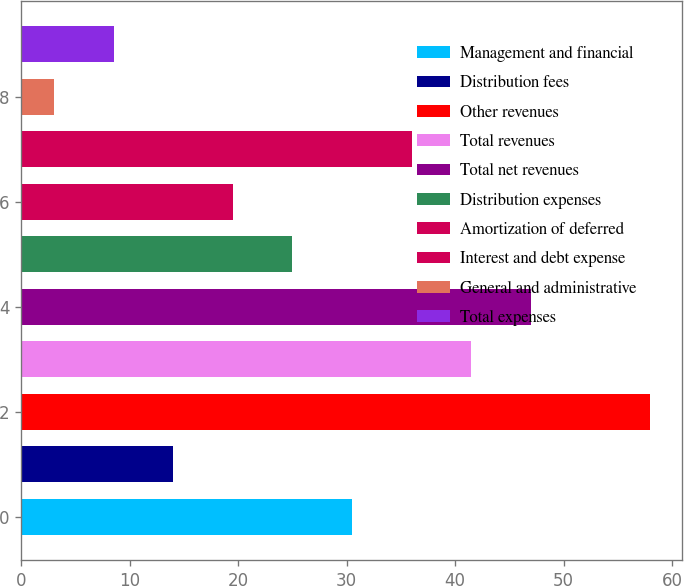<chart> <loc_0><loc_0><loc_500><loc_500><bar_chart><fcel>Management and financial<fcel>Distribution fees<fcel>Other revenues<fcel>Total revenues<fcel>Total net revenues<fcel>Distribution expenses<fcel>Amortization of deferred<fcel>Interest and debt expense<fcel>General and administrative<fcel>Total expenses<nl><fcel>30.5<fcel>14<fcel>58<fcel>41.5<fcel>47<fcel>25<fcel>19.5<fcel>36<fcel>3<fcel>8.5<nl></chart> 